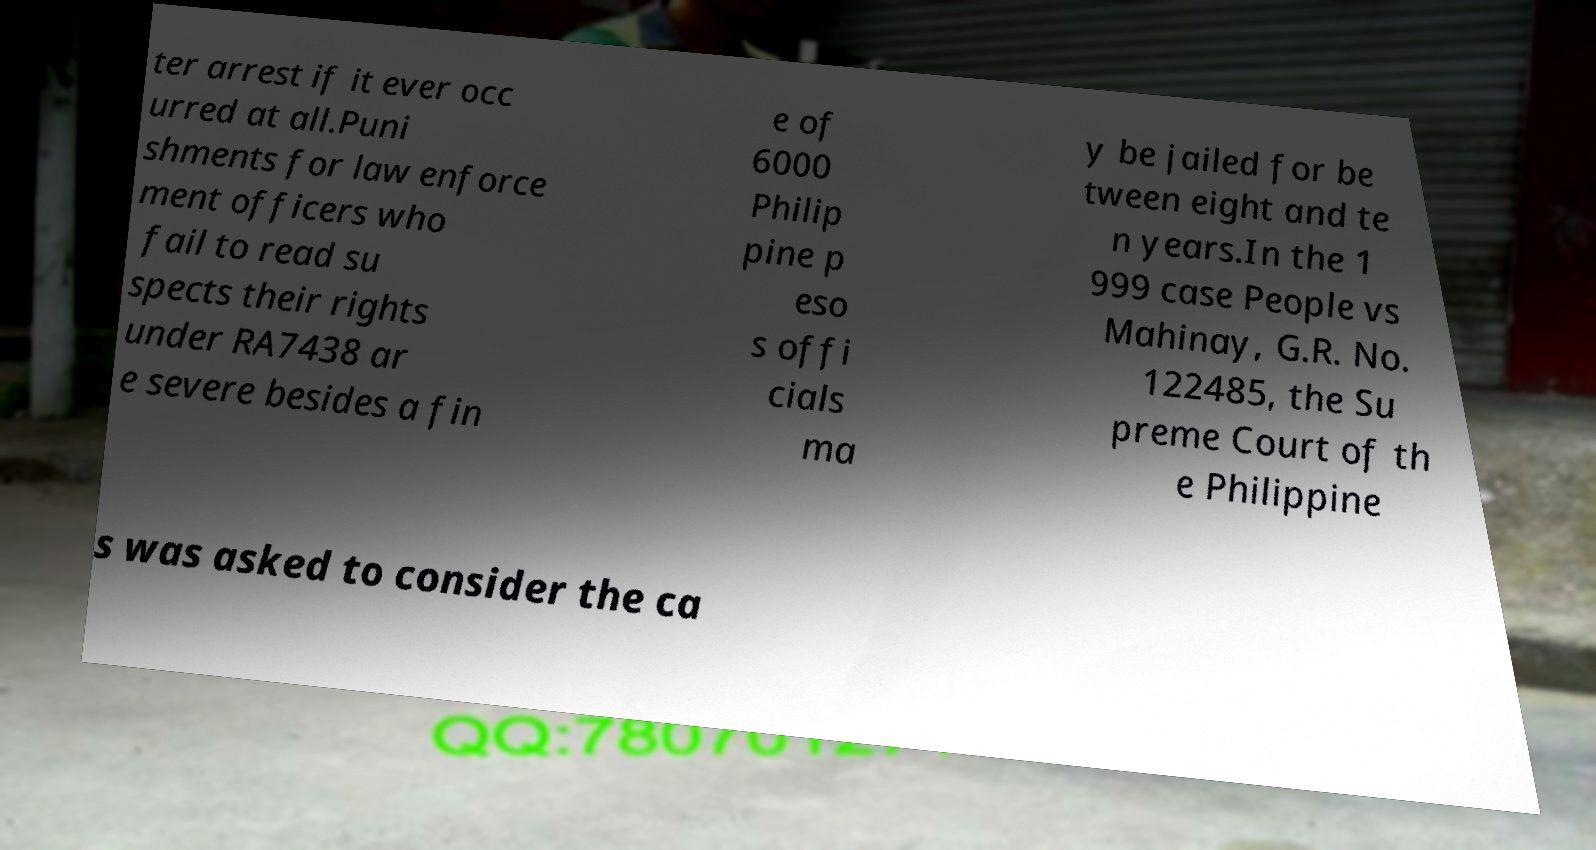Can you accurately transcribe the text from the provided image for me? ter arrest if it ever occ urred at all.Puni shments for law enforce ment officers who fail to read su spects their rights under RA7438 ar e severe besides a fin e of 6000 Philip pine p eso s offi cials ma y be jailed for be tween eight and te n years.In the 1 999 case People vs Mahinay, G.R. No. 122485, the Su preme Court of th e Philippine s was asked to consider the ca 